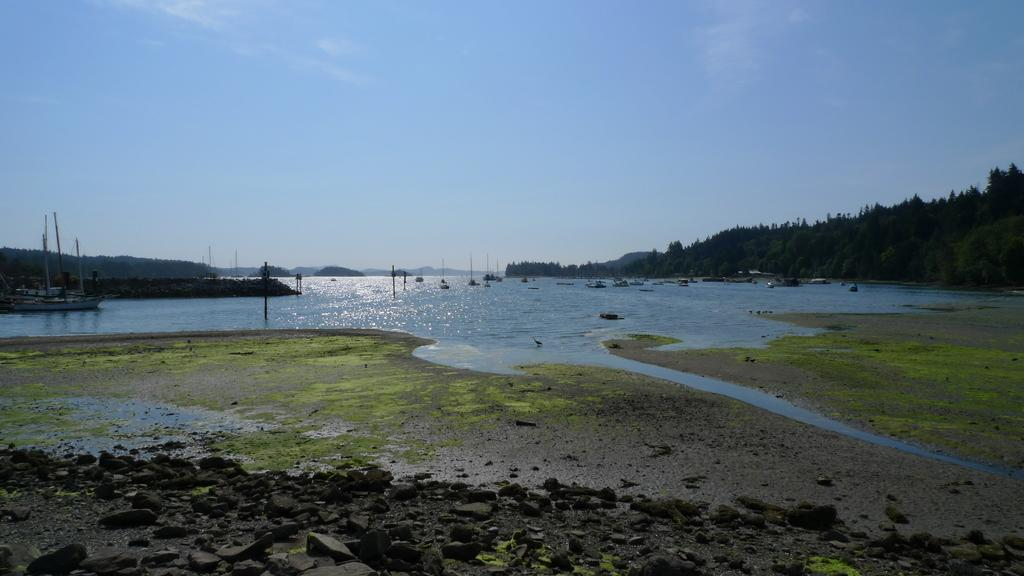What type of natural elements can be seen in the image? There are stones, grass, trees, and hills visible in the image. What is the water in the image used for? The water in the image is used for boats to navigate. What is visible in the background of the image? The sky is visible in the background of the image. Where is the doll's patch located in the image? There is no doll or patch present in the image. What type of trip can be taken in the image? The image does not depict a trip or any form of transportation other than the boats on the water. 